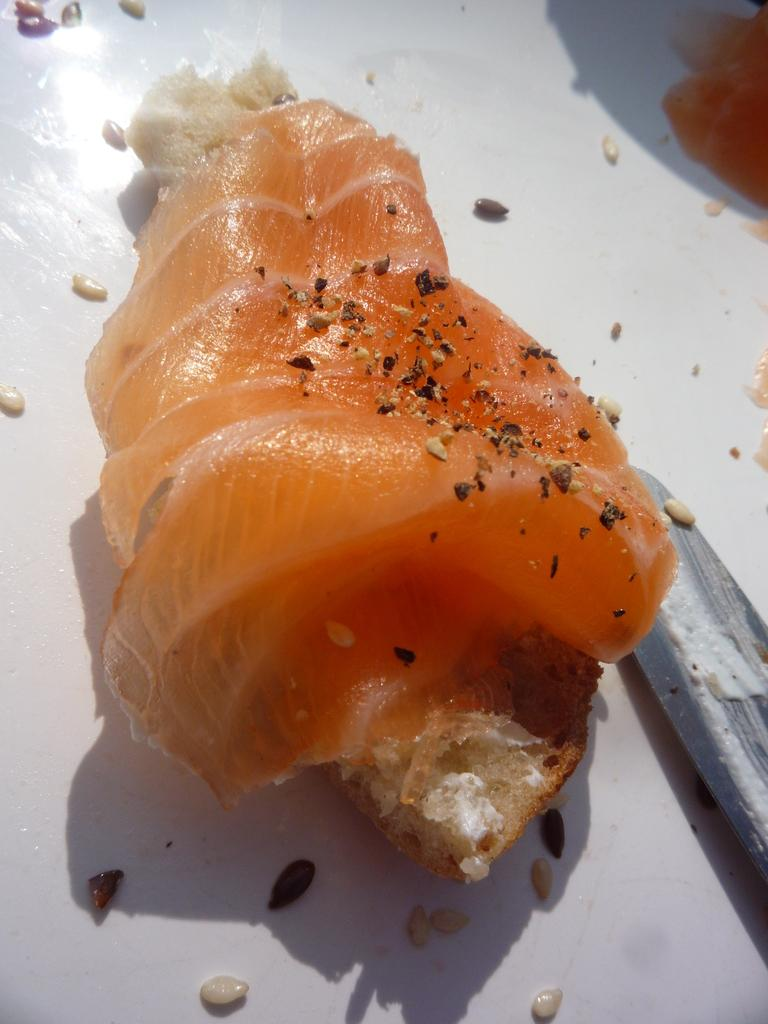What is present on the plate in the image? There are food items on a plate in the image. How many children are playing with celery on the trail in the image? There are no children, celery, or trail present in the image. The image only contains food items on a plate. 